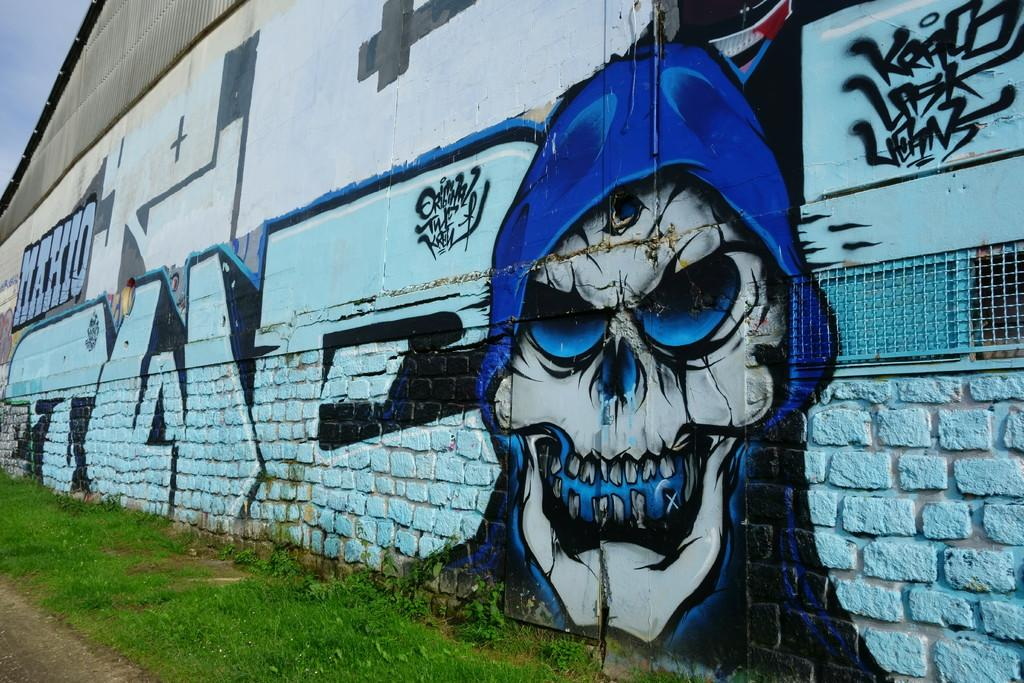What type of natural elements can be seen in the image? There is grass and plants in the image. What structure is located in the middle of the image? There is a wall in the middle of the image. What is featured on the wall in the image? The wall contains an art piece. What part of the sky is visible in the image? There is sky visible in the top left of the image. What type of pain is the person experiencing in the image? There is no person present in the image, and therefore no indication of pain. Can you describe the crook's role in the image? There is no crook present in the image. 